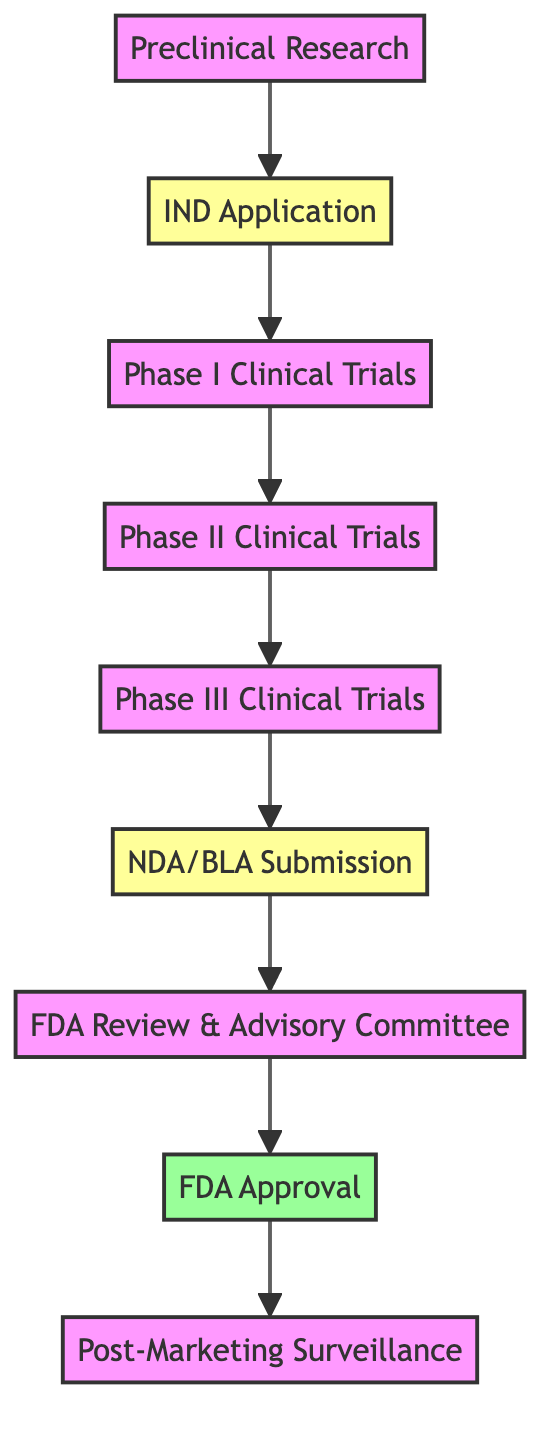What is the first step in the workflow? The diagram shows "Preclinical Research" as the starting point from node A.
Answer: Preclinical Research How many phases are there in the clinical trials? The diagram includes three phases: Phase I, Phase II, and Phase III, which are represented by nodes C, D, and E.
Answer: Three Which step involves the submission of an NDA/BLA? In the workflow, the step where an NDA/BLA is submitted is shown as node F, immediately following Phase III Clinical Trials.
Answer: NDA/BLA Submission What is the last step of the workflow? The final step represented in the diagram is "Post-Marketing Surveillance" indicated by node I.
Answer: Post-Marketing Surveillance What happens after FDA Approval? After the FDA Approval (node H), the next activity outlined is "Post-Marketing Surveillance" (node I), which indicates ongoing monitoring.
Answer: Post-Marketing Surveillance Which steps are classified under default nodes? The diagram shows nodes A, C, D, E, G, and I as default nodes, meaning these steps do not have a specific classification like submission or approval.
Answer: Six How many submissions are made in total? There are two submissions indicated in the diagram: the IND Application (node B) and the NDA/BLA Submission (node F).
Answer: Two What type of committee may be involved during FDA Review? The diagram specifies the involvement of an "independent advisory committee," which is noted in conjunction with the FDA Review step.
Answer: Advisory Committee What step follows Phase II Clinical Trials? The diagram indicates that Phase III Clinical Trials, represented by node E, follows directly after Phase II Clinical Trials at node D.
Answer: Phase III Clinical Trials 